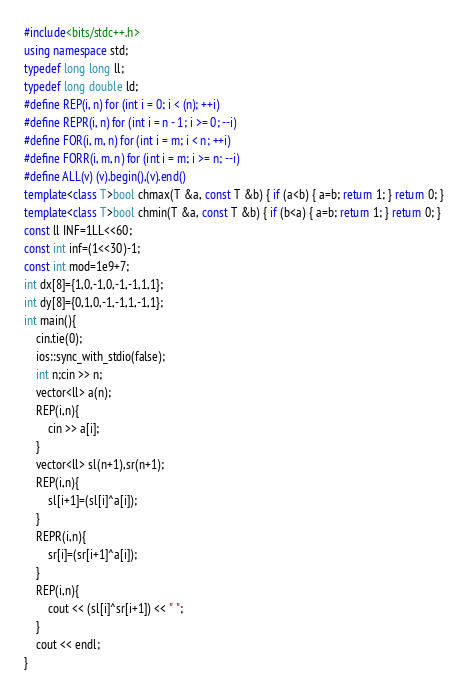<code> <loc_0><loc_0><loc_500><loc_500><_C++_>#include<bits/stdc++.h>
using namespace std;
typedef long long ll;
typedef long double ld;
#define REP(i, n) for (int i = 0; i < (n); ++i)
#define REPR(i, n) for (int i = n - 1; i >= 0; --i)
#define FOR(i, m, n) for (int i = m; i < n; ++i)
#define FORR(i, m, n) for (int i = m; i >= n; --i)
#define ALL(v) (v).begin(),(v).end()
template<class T>bool chmax(T &a, const T &b) { if (a<b) { a=b; return 1; } return 0; }
template<class T>bool chmin(T &a, const T &b) { if (b<a) { a=b; return 1; } return 0; }
const ll INF=1LL<<60;
const int inf=(1<<30)-1;
const int mod=1e9+7;
int dx[8]={1,0,-1,0,-1,-1,1,1};
int dy[8]={0,1,0,-1,-1,1,-1,1};
int main(){
    cin.tie(0);
    ios::sync_with_stdio(false);
    int n;cin >> n;
    vector<ll> a(n);
    REP(i,n){
        cin >> a[i];
    }
    vector<ll> sl(n+1),sr(n+1);
    REP(i,n){
        sl[i+1]=(sl[i]^a[i]);
    }
    REPR(i,n){
        sr[i]=(sr[i+1]^a[i]);
    }
    REP(i,n){
        cout << (sl[i]^sr[i+1]) << " ";
    }
    cout << endl;
}</code> 